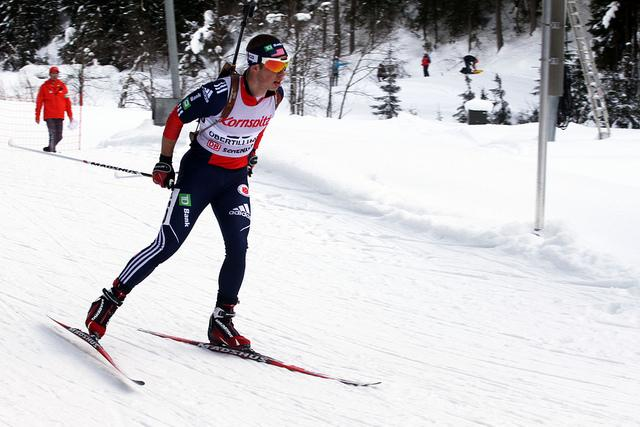What is required for this activity? skis 